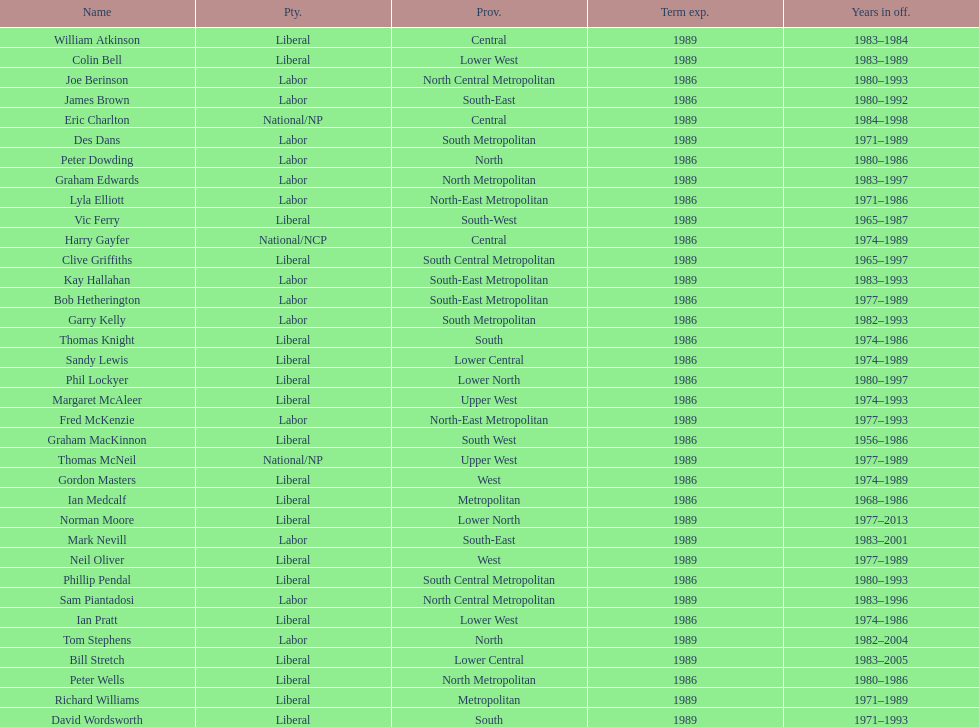Hame the last member listed whose last name begins with "p". Ian Pratt. 